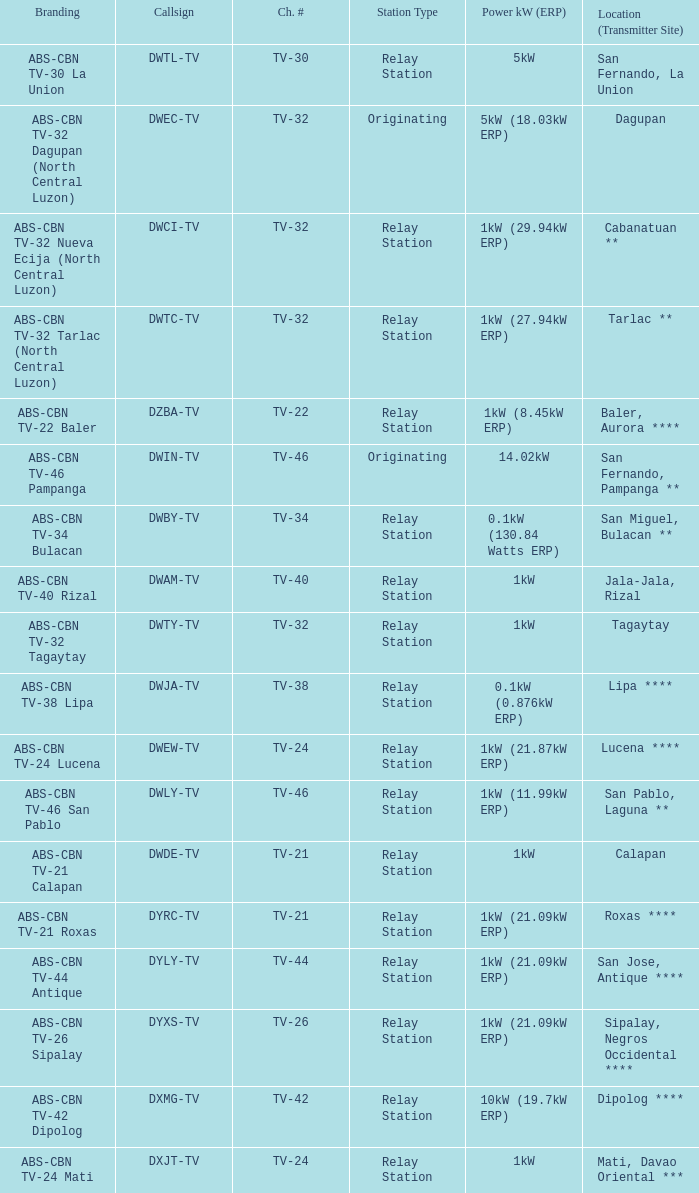Parse the full table. {'header': ['Branding', 'Callsign', 'Ch. #', 'Station Type', 'Power kW (ERP)', 'Location (Transmitter Site)'], 'rows': [['ABS-CBN TV-30 La Union', 'DWTL-TV', 'TV-30', 'Relay Station', '5kW', 'San Fernando, La Union'], ['ABS-CBN TV-32 Dagupan (North Central Luzon)', 'DWEC-TV', 'TV-32', 'Originating', '5kW (18.03kW ERP)', 'Dagupan'], ['ABS-CBN TV-32 Nueva Ecija (North Central Luzon)', 'DWCI-TV', 'TV-32', 'Relay Station', '1kW (29.94kW ERP)', 'Cabanatuan **'], ['ABS-CBN TV-32 Tarlac (North Central Luzon)', 'DWTC-TV', 'TV-32', 'Relay Station', '1kW (27.94kW ERP)', 'Tarlac **'], ['ABS-CBN TV-22 Baler', 'DZBA-TV', 'TV-22', 'Relay Station', '1kW (8.45kW ERP)', 'Baler, Aurora ****'], ['ABS-CBN TV-46 Pampanga', 'DWIN-TV', 'TV-46', 'Originating', '14.02kW', 'San Fernando, Pampanga **'], ['ABS-CBN TV-34 Bulacan', 'DWBY-TV', 'TV-34', 'Relay Station', '0.1kW (130.84 Watts ERP)', 'San Miguel, Bulacan **'], ['ABS-CBN TV-40 Rizal', 'DWAM-TV', 'TV-40', 'Relay Station', '1kW', 'Jala-Jala, Rizal'], ['ABS-CBN TV-32 Tagaytay', 'DWTY-TV', 'TV-32', 'Relay Station', '1kW', 'Tagaytay'], ['ABS-CBN TV-38 Lipa', 'DWJA-TV', 'TV-38', 'Relay Station', '0.1kW (0.876kW ERP)', 'Lipa ****'], ['ABS-CBN TV-24 Lucena', 'DWEW-TV', 'TV-24', 'Relay Station', '1kW (21.87kW ERP)', 'Lucena ****'], ['ABS-CBN TV-46 San Pablo', 'DWLY-TV', 'TV-46', 'Relay Station', '1kW (11.99kW ERP)', 'San Pablo, Laguna **'], ['ABS-CBN TV-21 Calapan', 'DWDE-TV', 'TV-21', 'Relay Station', '1kW', 'Calapan'], ['ABS-CBN TV-21 Roxas', 'DYRC-TV', 'TV-21', 'Relay Station', '1kW (21.09kW ERP)', 'Roxas ****'], ['ABS-CBN TV-44 Antique', 'DYLY-TV', 'TV-44', 'Relay Station', '1kW (21.09kW ERP)', 'San Jose, Antique ****'], ['ABS-CBN TV-26 Sipalay', 'DYXS-TV', 'TV-26', 'Relay Station', '1kW (21.09kW ERP)', 'Sipalay, Negros Occidental ****'], ['ABS-CBN TV-42 Dipolog', 'DXMG-TV', 'TV-42', 'Relay Station', '10kW (19.7kW ERP)', 'Dipolog ****'], ['ABS-CBN TV-24 Mati', 'DXJT-TV', 'TV-24', 'Relay Station', '1kW', 'Mati, Davao Oriental ***']]} The callsign DWEC-TV has what branding?  ABS-CBN TV-32 Dagupan (North Central Luzon). 